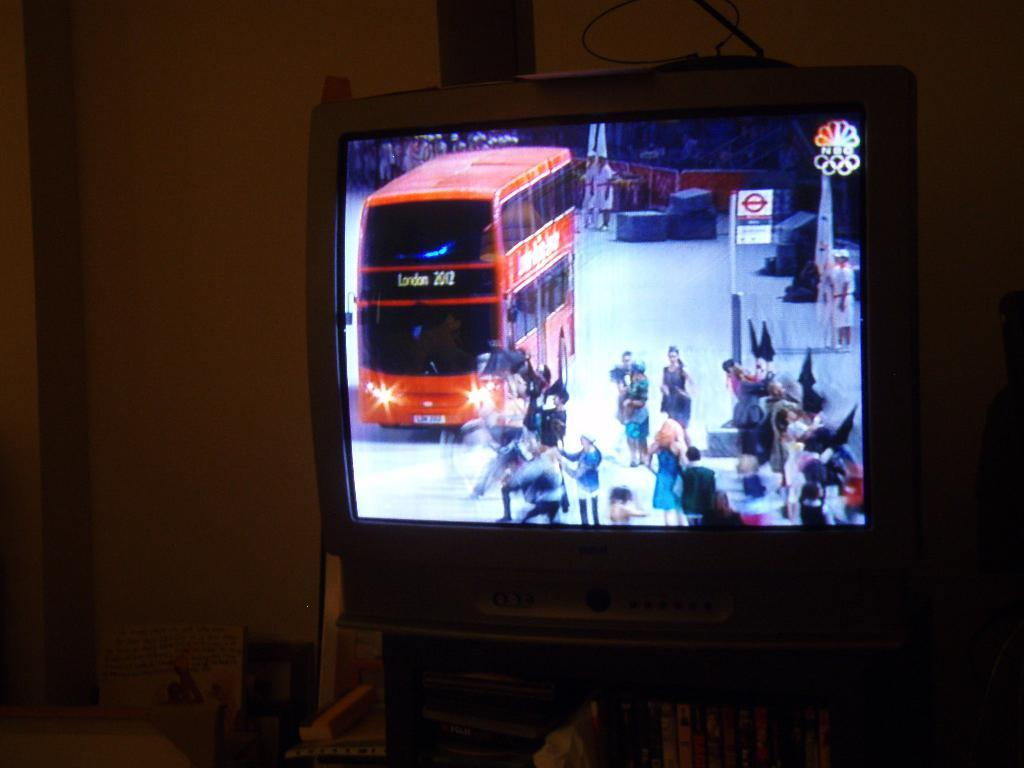<image>
Provide a brief description of the given image. A double decker bus going to London drives through the streets. 